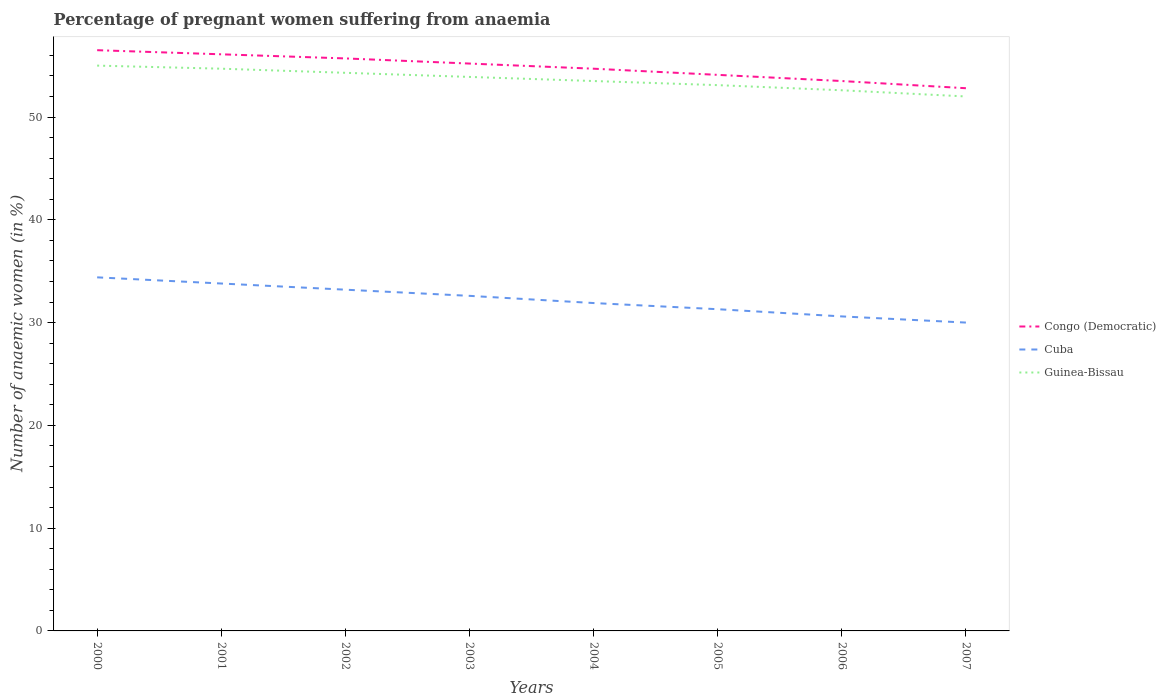How many different coloured lines are there?
Your answer should be compact. 3. Does the line corresponding to Congo (Democratic) intersect with the line corresponding to Guinea-Bissau?
Your answer should be compact. No. Across all years, what is the maximum number of anaemic women in Guinea-Bissau?
Your answer should be compact. 52. What is the total number of anaemic women in Cuba in the graph?
Make the answer very short. 0.6. What is the difference between the highest and the second highest number of anaemic women in Cuba?
Offer a very short reply. 4.4. What is the difference between the highest and the lowest number of anaemic women in Congo (Democratic)?
Offer a very short reply. 4. How many lines are there?
Offer a terse response. 3. What is the difference between two consecutive major ticks on the Y-axis?
Provide a short and direct response. 10. Does the graph contain any zero values?
Provide a succinct answer. No. Does the graph contain grids?
Your answer should be compact. No. Where does the legend appear in the graph?
Ensure brevity in your answer.  Center right. How many legend labels are there?
Your answer should be very brief. 3. What is the title of the graph?
Ensure brevity in your answer.  Percentage of pregnant women suffering from anaemia. What is the label or title of the X-axis?
Make the answer very short. Years. What is the label or title of the Y-axis?
Your answer should be very brief. Number of anaemic women (in %). What is the Number of anaemic women (in %) of Congo (Democratic) in 2000?
Offer a very short reply. 56.5. What is the Number of anaemic women (in %) in Cuba in 2000?
Offer a very short reply. 34.4. What is the Number of anaemic women (in %) of Guinea-Bissau in 2000?
Give a very brief answer. 55. What is the Number of anaemic women (in %) of Congo (Democratic) in 2001?
Provide a succinct answer. 56.1. What is the Number of anaemic women (in %) of Cuba in 2001?
Your answer should be very brief. 33.8. What is the Number of anaemic women (in %) of Guinea-Bissau in 2001?
Give a very brief answer. 54.7. What is the Number of anaemic women (in %) of Congo (Democratic) in 2002?
Give a very brief answer. 55.7. What is the Number of anaemic women (in %) in Cuba in 2002?
Keep it short and to the point. 33.2. What is the Number of anaemic women (in %) of Guinea-Bissau in 2002?
Provide a succinct answer. 54.3. What is the Number of anaemic women (in %) of Congo (Democratic) in 2003?
Make the answer very short. 55.2. What is the Number of anaemic women (in %) in Cuba in 2003?
Make the answer very short. 32.6. What is the Number of anaemic women (in %) in Guinea-Bissau in 2003?
Your answer should be compact. 53.9. What is the Number of anaemic women (in %) in Congo (Democratic) in 2004?
Your answer should be compact. 54.7. What is the Number of anaemic women (in %) of Cuba in 2004?
Your answer should be very brief. 31.9. What is the Number of anaemic women (in %) of Guinea-Bissau in 2004?
Provide a short and direct response. 53.5. What is the Number of anaemic women (in %) of Congo (Democratic) in 2005?
Provide a succinct answer. 54.1. What is the Number of anaemic women (in %) in Cuba in 2005?
Provide a short and direct response. 31.3. What is the Number of anaemic women (in %) in Guinea-Bissau in 2005?
Your answer should be very brief. 53.1. What is the Number of anaemic women (in %) of Congo (Democratic) in 2006?
Make the answer very short. 53.5. What is the Number of anaemic women (in %) in Cuba in 2006?
Your answer should be very brief. 30.6. What is the Number of anaemic women (in %) of Guinea-Bissau in 2006?
Your answer should be compact. 52.6. What is the Number of anaemic women (in %) of Congo (Democratic) in 2007?
Provide a short and direct response. 52.8. What is the Number of anaemic women (in %) of Guinea-Bissau in 2007?
Your response must be concise. 52. Across all years, what is the maximum Number of anaemic women (in %) of Congo (Democratic)?
Provide a short and direct response. 56.5. Across all years, what is the maximum Number of anaemic women (in %) in Cuba?
Give a very brief answer. 34.4. Across all years, what is the maximum Number of anaemic women (in %) of Guinea-Bissau?
Ensure brevity in your answer.  55. Across all years, what is the minimum Number of anaemic women (in %) of Congo (Democratic)?
Make the answer very short. 52.8. What is the total Number of anaemic women (in %) of Congo (Democratic) in the graph?
Offer a very short reply. 438.6. What is the total Number of anaemic women (in %) in Cuba in the graph?
Provide a short and direct response. 257.8. What is the total Number of anaemic women (in %) of Guinea-Bissau in the graph?
Keep it short and to the point. 429.1. What is the difference between the Number of anaemic women (in %) of Congo (Democratic) in 2000 and that in 2001?
Your answer should be compact. 0.4. What is the difference between the Number of anaemic women (in %) of Cuba in 2000 and that in 2001?
Ensure brevity in your answer.  0.6. What is the difference between the Number of anaemic women (in %) of Guinea-Bissau in 2000 and that in 2001?
Provide a short and direct response. 0.3. What is the difference between the Number of anaemic women (in %) of Guinea-Bissau in 2000 and that in 2002?
Ensure brevity in your answer.  0.7. What is the difference between the Number of anaemic women (in %) in Guinea-Bissau in 2000 and that in 2003?
Make the answer very short. 1.1. What is the difference between the Number of anaemic women (in %) in Guinea-Bissau in 2000 and that in 2004?
Offer a terse response. 1.5. What is the difference between the Number of anaemic women (in %) of Congo (Democratic) in 2000 and that in 2005?
Give a very brief answer. 2.4. What is the difference between the Number of anaemic women (in %) in Guinea-Bissau in 2000 and that in 2005?
Keep it short and to the point. 1.9. What is the difference between the Number of anaemic women (in %) in Congo (Democratic) in 2000 and that in 2006?
Provide a succinct answer. 3. What is the difference between the Number of anaemic women (in %) in Cuba in 2000 and that in 2006?
Your answer should be very brief. 3.8. What is the difference between the Number of anaemic women (in %) in Guinea-Bissau in 2000 and that in 2006?
Keep it short and to the point. 2.4. What is the difference between the Number of anaemic women (in %) in Congo (Democratic) in 2000 and that in 2007?
Keep it short and to the point. 3.7. What is the difference between the Number of anaemic women (in %) in Cuba in 2000 and that in 2007?
Your response must be concise. 4.4. What is the difference between the Number of anaemic women (in %) of Guinea-Bissau in 2000 and that in 2007?
Provide a succinct answer. 3. What is the difference between the Number of anaemic women (in %) in Congo (Democratic) in 2001 and that in 2003?
Give a very brief answer. 0.9. What is the difference between the Number of anaemic women (in %) of Cuba in 2001 and that in 2005?
Make the answer very short. 2.5. What is the difference between the Number of anaemic women (in %) of Guinea-Bissau in 2001 and that in 2005?
Your answer should be very brief. 1.6. What is the difference between the Number of anaemic women (in %) of Guinea-Bissau in 2001 and that in 2006?
Your answer should be compact. 2.1. What is the difference between the Number of anaemic women (in %) in Congo (Democratic) in 2002 and that in 2003?
Offer a very short reply. 0.5. What is the difference between the Number of anaemic women (in %) of Cuba in 2002 and that in 2003?
Ensure brevity in your answer.  0.6. What is the difference between the Number of anaemic women (in %) of Cuba in 2002 and that in 2005?
Give a very brief answer. 1.9. What is the difference between the Number of anaemic women (in %) in Congo (Democratic) in 2002 and that in 2006?
Provide a short and direct response. 2.2. What is the difference between the Number of anaemic women (in %) of Cuba in 2002 and that in 2006?
Your response must be concise. 2.6. What is the difference between the Number of anaemic women (in %) of Guinea-Bissau in 2002 and that in 2006?
Your response must be concise. 1.7. What is the difference between the Number of anaemic women (in %) of Congo (Democratic) in 2002 and that in 2007?
Keep it short and to the point. 2.9. What is the difference between the Number of anaemic women (in %) in Guinea-Bissau in 2002 and that in 2007?
Your response must be concise. 2.3. What is the difference between the Number of anaemic women (in %) of Cuba in 2003 and that in 2005?
Provide a short and direct response. 1.3. What is the difference between the Number of anaemic women (in %) of Guinea-Bissau in 2003 and that in 2005?
Make the answer very short. 0.8. What is the difference between the Number of anaemic women (in %) in Congo (Democratic) in 2003 and that in 2006?
Offer a terse response. 1.7. What is the difference between the Number of anaemic women (in %) in Guinea-Bissau in 2003 and that in 2006?
Keep it short and to the point. 1.3. What is the difference between the Number of anaemic women (in %) in Congo (Democratic) in 2004 and that in 2005?
Give a very brief answer. 0.6. What is the difference between the Number of anaemic women (in %) of Guinea-Bissau in 2004 and that in 2005?
Provide a short and direct response. 0.4. What is the difference between the Number of anaemic women (in %) of Guinea-Bissau in 2004 and that in 2006?
Your response must be concise. 0.9. What is the difference between the Number of anaemic women (in %) of Guinea-Bissau in 2005 and that in 2006?
Make the answer very short. 0.5. What is the difference between the Number of anaemic women (in %) in Cuba in 2005 and that in 2007?
Keep it short and to the point. 1.3. What is the difference between the Number of anaemic women (in %) in Guinea-Bissau in 2005 and that in 2007?
Provide a short and direct response. 1.1. What is the difference between the Number of anaemic women (in %) of Guinea-Bissau in 2006 and that in 2007?
Offer a very short reply. 0.6. What is the difference between the Number of anaemic women (in %) of Congo (Democratic) in 2000 and the Number of anaemic women (in %) of Cuba in 2001?
Your answer should be very brief. 22.7. What is the difference between the Number of anaemic women (in %) in Cuba in 2000 and the Number of anaemic women (in %) in Guinea-Bissau in 2001?
Your response must be concise. -20.3. What is the difference between the Number of anaemic women (in %) in Congo (Democratic) in 2000 and the Number of anaemic women (in %) in Cuba in 2002?
Your answer should be very brief. 23.3. What is the difference between the Number of anaemic women (in %) of Congo (Democratic) in 2000 and the Number of anaemic women (in %) of Guinea-Bissau in 2002?
Ensure brevity in your answer.  2.2. What is the difference between the Number of anaemic women (in %) in Cuba in 2000 and the Number of anaemic women (in %) in Guinea-Bissau in 2002?
Give a very brief answer. -19.9. What is the difference between the Number of anaemic women (in %) in Congo (Democratic) in 2000 and the Number of anaemic women (in %) in Cuba in 2003?
Provide a succinct answer. 23.9. What is the difference between the Number of anaemic women (in %) of Cuba in 2000 and the Number of anaemic women (in %) of Guinea-Bissau in 2003?
Your response must be concise. -19.5. What is the difference between the Number of anaemic women (in %) of Congo (Democratic) in 2000 and the Number of anaemic women (in %) of Cuba in 2004?
Your answer should be very brief. 24.6. What is the difference between the Number of anaemic women (in %) in Cuba in 2000 and the Number of anaemic women (in %) in Guinea-Bissau in 2004?
Give a very brief answer. -19.1. What is the difference between the Number of anaemic women (in %) of Congo (Democratic) in 2000 and the Number of anaemic women (in %) of Cuba in 2005?
Keep it short and to the point. 25.2. What is the difference between the Number of anaemic women (in %) of Cuba in 2000 and the Number of anaemic women (in %) of Guinea-Bissau in 2005?
Ensure brevity in your answer.  -18.7. What is the difference between the Number of anaemic women (in %) of Congo (Democratic) in 2000 and the Number of anaemic women (in %) of Cuba in 2006?
Make the answer very short. 25.9. What is the difference between the Number of anaemic women (in %) of Cuba in 2000 and the Number of anaemic women (in %) of Guinea-Bissau in 2006?
Make the answer very short. -18.2. What is the difference between the Number of anaemic women (in %) in Congo (Democratic) in 2000 and the Number of anaemic women (in %) in Cuba in 2007?
Ensure brevity in your answer.  26.5. What is the difference between the Number of anaemic women (in %) of Congo (Democratic) in 2000 and the Number of anaemic women (in %) of Guinea-Bissau in 2007?
Give a very brief answer. 4.5. What is the difference between the Number of anaemic women (in %) of Cuba in 2000 and the Number of anaemic women (in %) of Guinea-Bissau in 2007?
Make the answer very short. -17.6. What is the difference between the Number of anaemic women (in %) in Congo (Democratic) in 2001 and the Number of anaemic women (in %) in Cuba in 2002?
Your answer should be compact. 22.9. What is the difference between the Number of anaemic women (in %) of Congo (Democratic) in 2001 and the Number of anaemic women (in %) of Guinea-Bissau in 2002?
Provide a succinct answer. 1.8. What is the difference between the Number of anaemic women (in %) of Cuba in 2001 and the Number of anaemic women (in %) of Guinea-Bissau in 2002?
Your response must be concise. -20.5. What is the difference between the Number of anaemic women (in %) of Congo (Democratic) in 2001 and the Number of anaemic women (in %) of Cuba in 2003?
Provide a short and direct response. 23.5. What is the difference between the Number of anaemic women (in %) of Cuba in 2001 and the Number of anaemic women (in %) of Guinea-Bissau in 2003?
Keep it short and to the point. -20.1. What is the difference between the Number of anaemic women (in %) in Congo (Democratic) in 2001 and the Number of anaemic women (in %) in Cuba in 2004?
Provide a succinct answer. 24.2. What is the difference between the Number of anaemic women (in %) of Congo (Democratic) in 2001 and the Number of anaemic women (in %) of Guinea-Bissau in 2004?
Offer a very short reply. 2.6. What is the difference between the Number of anaemic women (in %) of Cuba in 2001 and the Number of anaemic women (in %) of Guinea-Bissau in 2004?
Ensure brevity in your answer.  -19.7. What is the difference between the Number of anaemic women (in %) of Congo (Democratic) in 2001 and the Number of anaemic women (in %) of Cuba in 2005?
Your response must be concise. 24.8. What is the difference between the Number of anaemic women (in %) in Congo (Democratic) in 2001 and the Number of anaemic women (in %) in Guinea-Bissau in 2005?
Give a very brief answer. 3. What is the difference between the Number of anaemic women (in %) of Cuba in 2001 and the Number of anaemic women (in %) of Guinea-Bissau in 2005?
Offer a very short reply. -19.3. What is the difference between the Number of anaemic women (in %) in Congo (Democratic) in 2001 and the Number of anaemic women (in %) in Cuba in 2006?
Offer a terse response. 25.5. What is the difference between the Number of anaemic women (in %) of Congo (Democratic) in 2001 and the Number of anaemic women (in %) of Guinea-Bissau in 2006?
Keep it short and to the point. 3.5. What is the difference between the Number of anaemic women (in %) of Cuba in 2001 and the Number of anaemic women (in %) of Guinea-Bissau in 2006?
Offer a very short reply. -18.8. What is the difference between the Number of anaemic women (in %) of Congo (Democratic) in 2001 and the Number of anaemic women (in %) of Cuba in 2007?
Provide a short and direct response. 26.1. What is the difference between the Number of anaemic women (in %) of Cuba in 2001 and the Number of anaemic women (in %) of Guinea-Bissau in 2007?
Offer a terse response. -18.2. What is the difference between the Number of anaemic women (in %) in Congo (Democratic) in 2002 and the Number of anaemic women (in %) in Cuba in 2003?
Your answer should be very brief. 23.1. What is the difference between the Number of anaemic women (in %) in Congo (Democratic) in 2002 and the Number of anaemic women (in %) in Guinea-Bissau in 2003?
Give a very brief answer. 1.8. What is the difference between the Number of anaemic women (in %) of Cuba in 2002 and the Number of anaemic women (in %) of Guinea-Bissau in 2003?
Keep it short and to the point. -20.7. What is the difference between the Number of anaemic women (in %) of Congo (Democratic) in 2002 and the Number of anaemic women (in %) of Cuba in 2004?
Ensure brevity in your answer.  23.8. What is the difference between the Number of anaemic women (in %) of Cuba in 2002 and the Number of anaemic women (in %) of Guinea-Bissau in 2004?
Your answer should be very brief. -20.3. What is the difference between the Number of anaemic women (in %) in Congo (Democratic) in 2002 and the Number of anaemic women (in %) in Cuba in 2005?
Provide a short and direct response. 24.4. What is the difference between the Number of anaemic women (in %) in Cuba in 2002 and the Number of anaemic women (in %) in Guinea-Bissau in 2005?
Your answer should be compact. -19.9. What is the difference between the Number of anaemic women (in %) of Congo (Democratic) in 2002 and the Number of anaemic women (in %) of Cuba in 2006?
Your response must be concise. 25.1. What is the difference between the Number of anaemic women (in %) of Congo (Democratic) in 2002 and the Number of anaemic women (in %) of Guinea-Bissau in 2006?
Your answer should be very brief. 3.1. What is the difference between the Number of anaemic women (in %) in Cuba in 2002 and the Number of anaemic women (in %) in Guinea-Bissau in 2006?
Give a very brief answer. -19.4. What is the difference between the Number of anaemic women (in %) in Congo (Democratic) in 2002 and the Number of anaemic women (in %) in Cuba in 2007?
Provide a succinct answer. 25.7. What is the difference between the Number of anaemic women (in %) of Cuba in 2002 and the Number of anaemic women (in %) of Guinea-Bissau in 2007?
Provide a succinct answer. -18.8. What is the difference between the Number of anaemic women (in %) of Congo (Democratic) in 2003 and the Number of anaemic women (in %) of Cuba in 2004?
Provide a short and direct response. 23.3. What is the difference between the Number of anaemic women (in %) in Congo (Democratic) in 2003 and the Number of anaemic women (in %) in Guinea-Bissau in 2004?
Offer a very short reply. 1.7. What is the difference between the Number of anaemic women (in %) in Cuba in 2003 and the Number of anaemic women (in %) in Guinea-Bissau in 2004?
Provide a succinct answer. -20.9. What is the difference between the Number of anaemic women (in %) of Congo (Democratic) in 2003 and the Number of anaemic women (in %) of Cuba in 2005?
Ensure brevity in your answer.  23.9. What is the difference between the Number of anaemic women (in %) of Congo (Democratic) in 2003 and the Number of anaemic women (in %) of Guinea-Bissau in 2005?
Offer a terse response. 2.1. What is the difference between the Number of anaemic women (in %) of Cuba in 2003 and the Number of anaemic women (in %) of Guinea-Bissau in 2005?
Ensure brevity in your answer.  -20.5. What is the difference between the Number of anaemic women (in %) of Congo (Democratic) in 2003 and the Number of anaemic women (in %) of Cuba in 2006?
Provide a short and direct response. 24.6. What is the difference between the Number of anaemic women (in %) of Congo (Democratic) in 2003 and the Number of anaemic women (in %) of Cuba in 2007?
Give a very brief answer. 25.2. What is the difference between the Number of anaemic women (in %) in Cuba in 2003 and the Number of anaemic women (in %) in Guinea-Bissau in 2007?
Your response must be concise. -19.4. What is the difference between the Number of anaemic women (in %) in Congo (Democratic) in 2004 and the Number of anaemic women (in %) in Cuba in 2005?
Make the answer very short. 23.4. What is the difference between the Number of anaemic women (in %) in Cuba in 2004 and the Number of anaemic women (in %) in Guinea-Bissau in 2005?
Ensure brevity in your answer.  -21.2. What is the difference between the Number of anaemic women (in %) in Congo (Democratic) in 2004 and the Number of anaemic women (in %) in Cuba in 2006?
Keep it short and to the point. 24.1. What is the difference between the Number of anaemic women (in %) in Congo (Democratic) in 2004 and the Number of anaemic women (in %) in Guinea-Bissau in 2006?
Keep it short and to the point. 2.1. What is the difference between the Number of anaemic women (in %) in Cuba in 2004 and the Number of anaemic women (in %) in Guinea-Bissau in 2006?
Provide a succinct answer. -20.7. What is the difference between the Number of anaemic women (in %) in Congo (Democratic) in 2004 and the Number of anaemic women (in %) in Cuba in 2007?
Give a very brief answer. 24.7. What is the difference between the Number of anaemic women (in %) in Cuba in 2004 and the Number of anaemic women (in %) in Guinea-Bissau in 2007?
Your response must be concise. -20.1. What is the difference between the Number of anaemic women (in %) in Congo (Democratic) in 2005 and the Number of anaemic women (in %) in Guinea-Bissau in 2006?
Keep it short and to the point. 1.5. What is the difference between the Number of anaemic women (in %) of Cuba in 2005 and the Number of anaemic women (in %) of Guinea-Bissau in 2006?
Give a very brief answer. -21.3. What is the difference between the Number of anaemic women (in %) in Congo (Democratic) in 2005 and the Number of anaemic women (in %) in Cuba in 2007?
Ensure brevity in your answer.  24.1. What is the difference between the Number of anaemic women (in %) of Congo (Democratic) in 2005 and the Number of anaemic women (in %) of Guinea-Bissau in 2007?
Offer a very short reply. 2.1. What is the difference between the Number of anaemic women (in %) in Cuba in 2005 and the Number of anaemic women (in %) in Guinea-Bissau in 2007?
Your response must be concise. -20.7. What is the difference between the Number of anaemic women (in %) in Congo (Democratic) in 2006 and the Number of anaemic women (in %) in Cuba in 2007?
Your answer should be very brief. 23.5. What is the difference between the Number of anaemic women (in %) in Cuba in 2006 and the Number of anaemic women (in %) in Guinea-Bissau in 2007?
Your answer should be very brief. -21.4. What is the average Number of anaemic women (in %) in Congo (Democratic) per year?
Ensure brevity in your answer.  54.83. What is the average Number of anaemic women (in %) in Cuba per year?
Provide a short and direct response. 32.23. What is the average Number of anaemic women (in %) of Guinea-Bissau per year?
Give a very brief answer. 53.64. In the year 2000, what is the difference between the Number of anaemic women (in %) of Congo (Democratic) and Number of anaemic women (in %) of Cuba?
Provide a short and direct response. 22.1. In the year 2000, what is the difference between the Number of anaemic women (in %) of Cuba and Number of anaemic women (in %) of Guinea-Bissau?
Your answer should be compact. -20.6. In the year 2001, what is the difference between the Number of anaemic women (in %) of Congo (Democratic) and Number of anaemic women (in %) of Cuba?
Offer a terse response. 22.3. In the year 2001, what is the difference between the Number of anaemic women (in %) in Cuba and Number of anaemic women (in %) in Guinea-Bissau?
Provide a succinct answer. -20.9. In the year 2002, what is the difference between the Number of anaemic women (in %) in Congo (Democratic) and Number of anaemic women (in %) in Cuba?
Make the answer very short. 22.5. In the year 2002, what is the difference between the Number of anaemic women (in %) in Congo (Democratic) and Number of anaemic women (in %) in Guinea-Bissau?
Your response must be concise. 1.4. In the year 2002, what is the difference between the Number of anaemic women (in %) in Cuba and Number of anaemic women (in %) in Guinea-Bissau?
Your answer should be compact. -21.1. In the year 2003, what is the difference between the Number of anaemic women (in %) of Congo (Democratic) and Number of anaemic women (in %) of Cuba?
Provide a short and direct response. 22.6. In the year 2003, what is the difference between the Number of anaemic women (in %) in Congo (Democratic) and Number of anaemic women (in %) in Guinea-Bissau?
Your answer should be compact. 1.3. In the year 2003, what is the difference between the Number of anaemic women (in %) of Cuba and Number of anaemic women (in %) of Guinea-Bissau?
Give a very brief answer. -21.3. In the year 2004, what is the difference between the Number of anaemic women (in %) in Congo (Democratic) and Number of anaemic women (in %) in Cuba?
Provide a short and direct response. 22.8. In the year 2004, what is the difference between the Number of anaemic women (in %) in Cuba and Number of anaemic women (in %) in Guinea-Bissau?
Your answer should be very brief. -21.6. In the year 2005, what is the difference between the Number of anaemic women (in %) in Congo (Democratic) and Number of anaemic women (in %) in Cuba?
Provide a short and direct response. 22.8. In the year 2005, what is the difference between the Number of anaemic women (in %) in Cuba and Number of anaemic women (in %) in Guinea-Bissau?
Make the answer very short. -21.8. In the year 2006, what is the difference between the Number of anaemic women (in %) in Congo (Democratic) and Number of anaemic women (in %) in Cuba?
Give a very brief answer. 22.9. In the year 2007, what is the difference between the Number of anaemic women (in %) of Congo (Democratic) and Number of anaemic women (in %) of Cuba?
Make the answer very short. 22.8. What is the ratio of the Number of anaemic women (in %) in Congo (Democratic) in 2000 to that in 2001?
Offer a very short reply. 1.01. What is the ratio of the Number of anaemic women (in %) in Cuba in 2000 to that in 2001?
Keep it short and to the point. 1.02. What is the ratio of the Number of anaemic women (in %) in Guinea-Bissau in 2000 to that in 2001?
Your response must be concise. 1.01. What is the ratio of the Number of anaemic women (in %) in Congo (Democratic) in 2000 to that in 2002?
Make the answer very short. 1.01. What is the ratio of the Number of anaemic women (in %) of Cuba in 2000 to that in 2002?
Give a very brief answer. 1.04. What is the ratio of the Number of anaemic women (in %) in Guinea-Bissau in 2000 to that in 2002?
Keep it short and to the point. 1.01. What is the ratio of the Number of anaemic women (in %) of Congo (Democratic) in 2000 to that in 2003?
Give a very brief answer. 1.02. What is the ratio of the Number of anaemic women (in %) of Cuba in 2000 to that in 2003?
Your answer should be compact. 1.06. What is the ratio of the Number of anaemic women (in %) of Guinea-Bissau in 2000 to that in 2003?
Provide a succinct answer. 1.02. What is the ratio of the Number of anaemic women (in %) of Congo (Democratic) in 2000 to that in 2004?
Offer a very short reply. 1.03. What is the ratio of the Number of anaemic women (in %) in Cuba in 2000 to that in 2004?
Your answer should be compact. 1.08. What is the ratio of the Number of anaemic women (in %) of Guinea-Bissau in 2000 to that in 2004?
Offer a terse response. 1.03. What is the ratio of the Number of anaemic women (in %) in Congo (Democratic) in 2000 to that in 2005?
Your response must be concise. 1.04. What is the ratio of the Number of anaemic women (in %) in Cuba in 2000 to that in 2005?
Provide a succinct answer. 1.1. What is the ratio of the Number of anaemic women (in %) in Guinea-Bissau in 2000 to that in 2005?
Offer a terse response. 1.04. What is the ratio of the Number of anaemic women (in %) in Congo (Democratic) in 2000 to that in 2006?
Offer a terse response. 1.06. What is the ratio of the Number of anaemic women (in %) of Cuba in 2000 to that in 2006?
Keep it short and to the point. 1.12. What is the ratio of the Number of anaemic women (in %) in Guinea-Bissau in 2000 to that in 2006?
Provide a succinct answer. 1.05. What is the ratio of the Number of anaemic women (in %) in Congo (Democratic) in 2000 to that in 2007?
Give a very brief answer. 1.07. What is the ratio of the Number of anaemic women (in %) in Cuba in 2000 to that in 2007?
Offer a terse response. 1.15. What is the ratio of the Number of anaemic women (in %) of Guinea-Bissau in 2000 to that in 2007?
Your answer should be very brief. 1.06. What is the ratio of the Number of anaemic women (in %) of Cuba in 2001 to that in 2002?
Provide a succinct answer. 1.02. What is the ratio of the Number of anaemic women (in %) in Guinea-Bissau in 2001 to that in 2002?
Your answer should be very brief. 1.01. What is the ratio of the Number of anaemic women (in %) of Congo (Democratic) in 2001 to that in 2003?
Give a very brief answer. 1.02. What is the ratio of the Number of anaemic women (in %) of Cuba in 2001 to that in 2003?
Keep it short and to the point. 1.04. What is the ratio of the Number of anaemic women (in %) in Guinea-Bissau in 2001 to that in 2003?
Your response must be concise. 1.01. What is the ratio of the Number of anaemic women (in %) in Congo (Democratic) in 2001 to that in 2004?
Give a very brief answer. 1.03. What is the ratio of the Number of anaemic women (in %) in Cuba in 2001 to that in 2004?
Provide a short and direct response. 1.06. What is the ratio of the Number of anaemic women (in %) in Guinea-Bissau in 2001 to that in 2004?
Your response must be concise. 1.02. What is the ratio of the Number of anaemic women (in %) of Congo (Democratic) in 2001 to that in 2005?
Provide a short and direct response. 1.04. What is the ratio of the Number of anaemic women (in %) of Cuba in 2001 to that in 2005?
Keep it short and to the point. 1.08. What is the ratio of the Number of anaemic women (in %) of Guinea-Bissau in 2001 to that in 2005?
Offer a very short reply. 1.03. What is the ratio of the Number of anaemic women (in %) of Congo (Democratic) in 2001 to that in 2006?
Provide a short and direct response. 1.05. What is the ratio of the Number of anaemic women (in %) in Cuba in 2001 to that in 2006?
Offer a very short reply. 1.1. What is the ratio of the Number of anaemic women (in %) in Guinea-Bissau in 2001 to that in 2006?
Provide a succinct answer. 1.04. What is the ratio of the Number of anaemic women (in %) in Cuba in 2001 to that in 2007?
Give a very brief answer. 1.13. What is the ratio of the Number of anaemic women (in %) in Guinea-Bissau in 2001 to that in 2007?
Your answer should be compact. 1.05. What is the ratio of the Number of anaemic women (in %) in Congo (Democratic) in 2002 to that in 2003?
Your response must be concise. 1.01. What is the ratio of the Number of anaemic women (in %) in Cuba in 2002 to that in 2003?
Provide a short and direct response. 1.02. What is the ratio of the Number of anaemic women (in %) in Guinea-Bissau in 2002 to that in 2003?
Keep it short and to the point. 1.01. What is the ratio of the Number of anaemic women (in %) in Congo (Democratic) in 2002 to that in 2004?
Offer a very short reply. 1.02. What is the ratio of the Number of anaemic women (in %) of Cuba in 2002 to that in 2004?
Your answer should be very brief. 1.04. What is the ratio of the Number of anaemic women (in %) in Congo (Democratic) in 2002 to that in 2005?
Provide a succinct answer. 1.03. What is the ratio of the Number of anaemic women (in %) of Cuba in 2002 to that in 2005?
Make the answer very short. 1.06. What is the ratio of the Number of anaemic women (in %) of Guinea-Bissau in 2002 to that in 2005?
Ensure brevity in your answer.  1.02. What is the ratio of the Number of anaemic women (in %) of Congo (Democratic) in 2002 to that in 2006?
Provide a succinct answer. 1.04. What is the ratio of the Number of anaemic women (in %) of Cuba in 2002 to that in 2006?
Make the answer very short. 1.08. What is the ratio of the Number of anaemic women (in %) in Guinea-Bissau in 2002 to that in 2006?
Your response must be concise. 1.03. What is the ratio of the Number of anaemic women (in %) in Congo (Democratic) in 2002 to that in 2007?
Your answer should be compact. 1.05. What is the ratio of the Number of anaemic women (in %) in Cuba in 2002 to that in 2007?
Offer a terse response. 1.11. What is the ratio of the Number of anaemic women (in %) in Guinea-Bissau in 2002 to that in 2007?
Make the answer very short. 1.04. What is the ratio of the Number of anaemic women (in %) in Congo (Democratic) in 2003 to that in 2004?
Provide a succinct answer. 1.01. What is the ratio of the Number of anaemic women (in %) in Cuba in 2003 to that in 2004?
Provide a succinct answer. 1.02. What is the ratio of the Number of anaemic women (in %) in Guinea-Bissau in 2003 to that in 2004?
Offer a very short reply. 1.01. What is the ratio of the Number of anaemic women (in %) of Congo (Democratic) in 2003 to that in 2005?
Make the answer very short. 1.02. What is the ratio of the Number of anaemic women (in %) in Cuba in 2003 to that in 2005?
Give a very brief answer. 1.04. What is the ratio of the Number of anaemic women (in %) of Guinea-Bissau in 2003 to that in 2005?
Give a very brief answer. 1.02. What is the ratio of the Number of anaemic women (in %) in Congo (Democratic) in 2003 to that in 2006?
Make the answer very short. 1.03. What is the ratio of the Number of anaemic women (in %) of Cuba in 2003 to that in 2006?
Your response must be concise. 1.07. What is the ratio of the Number of anaemic women (in %) in Guinea-Bissau in 2003 to that in 2006?
Offer a terse response. 1.02. What is the ratio of the Number of anaemic women (in %) in Congo (Democratic) in 2003 to that in 2007?
Offer a very short reply. 1.05. What is the ratio of the Number of anaemic women (in %) of Cuba in 2003 to that in 2007?
Your response must be concise. 1.09. What is the ratio of the Number of anaemic women (in %) of Guinea-Bissau in 2003 to that in 2007?
Provide a short and direct response. 1.04. What is the ratio of the Number of anaemic women (in %) of Congo (Democratic) in 2004 to that in 2005?
Make the answer very short. 1.01. What is the ratio of the Number of anaemic women (in %) of Cuba in 2004 to that in 2005?
Make the answer very short. 1.02. What is the ratio of the Number of anaemic women (in %) in Guinea-Bissau in 2004 to that in 2005?
Offer a very short reply. 1.01. What is the ratio of the Number of anaemic women (in %) of Congo (Democratic) in 2004 to that in 2006?
Your answer should be very brief. 1.02. What is the ratio of the Number of anaemic women (in %) of Cuba in 2004 to that in 2006?
Give a very brief answer. 1.04. What is the ratio of the Number of anaemic women (in %) in Guinea-Bissau in 2004 to that in 2006?
Your answer should be compact. 1.02. What is the ratio of the Number of anaemic women (in %) in Congo (Democratic) in 2004 to that in 2007?
Provide a succinct answer. 1.04. What is the ratio of the Number of anaemic women (in %) of Cuba in 2004 to that in 2007?
Give a very brief answer. 1.06. What is the ratio of the Number of anaemic women (in %) in Guinea-Bissau in 2004 to that in 2007?
Keep it short and to the point. 1.03. What is the ratio of the Number of anaemic women (in %) in Congo (Democratic) in 2005 to that in 2006?
Offer a terse response. 1.01. What is the ratio of the Number of anaemic women (in %) of Cuba in 2005 to that in 2006?
Your response must be concise. 1.02. What is the ratio of the Number of anaemic women (in %) in Guinea-Bissau in 2005 to that in 2006?
Give a very brief answer. 1.01. What is the ratio of the Number of anaemic women (in %) in Congo (Democratic) in 2005 to that in 2007?
Your answer should be compact. 1.02. What is the ratio of the Number of anaemic women (in %) in Cuba in 2005 to that in 2007?
Provide a short and direct response. 1.04. What is the ratio of the Number of anaemic women (in %) in Guinea-Bissau in 2005 to that in 2007?
Provide a short and direct response. 1.02. What is the ratio of the Number of anaemic women (in %) in Congo (Democratic) in 2006 to that in 2007?
Offer a very short reply. 1.01. What is the ratio of the Number of anaemic women (in %) of Cuba in 2006 to that in 2007?
Provide a short and direct response. 1.02. What is the ratio of the Number of anaemic women (in %) of Guinea-Bissau in 2006 to that in 2007?
Provide a succinct answer. 1.01. What is the difference between the highest and the lowest Number of anaemic women (in %) of Cuba?
Ensure brevity in your answer.  4.4. What is the difference between the highest and the lowest Number of anaemic women (in %) of Guinea-Bissau?
Offer a terse response. 3. 